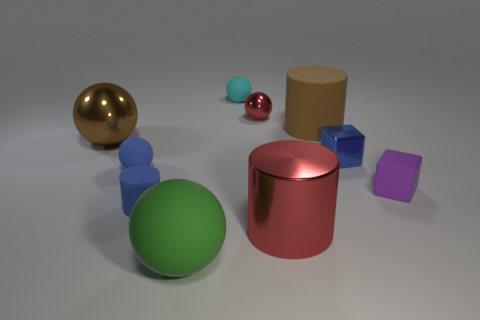Subtract all green spheres. How many spheres are left? 4 Subtract all purple balls. Subtract all green blocks. How many balls are left? 5 Subtract all cylinders. How many objects are left? 7 Subtract 0 gray blocks. How many objects are left? 10 Subtract all brown metal spheres. Subtract all large brown matte cylinders. How many objects are left? 8 Add 9 small purple matte cubes. How many small purple matte cubes are left? 10 Add 1 blue balls. How many blue balls exist? 2 